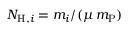Convert formula to latex. <formula><loc_0><loc_0><loc_500><loc_500>N _ { H , i } = m _ { i } / ( \mu \, m _ { P } )</formula> 